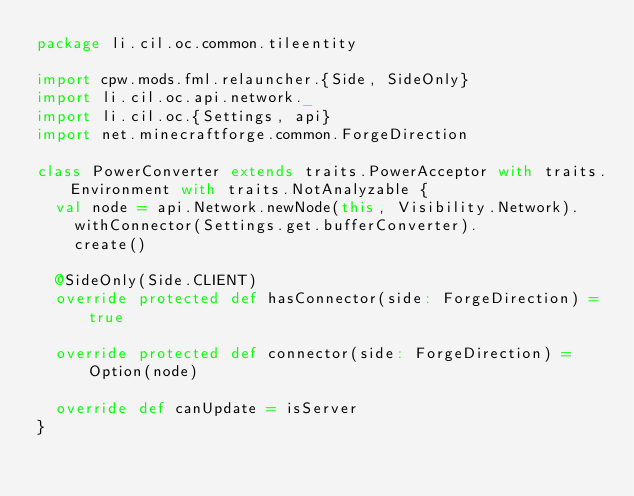Convert code to text. <code><loc_0><loc_0><loc_500><loc_500><_Scala_>package li.cil.oc.common.tileentity

import cpw.mods.fml.relauncher.{Side, SideOnly}
import li.cil.oc.api.network._
import li.cil.oc.{Settings, api}
import net.minecraftforge.common.ForgeDirection

class PowerConverter extends traits.PowerAcceptor with traits.Environment with traits.NotAnalyzable {
  val node = api.Network.newNode(this, Visibility.Network).
    withConnector(Settings.get.bufferConverter).
    create()

  @SideOnly(Side.CLIENT)
  override protected def hasConnector(side: ForgeDirection) = true

  override protected def connector(side: ForgeDirection) = Option(node)

  override def canUpdate = isServer
}
</code> 